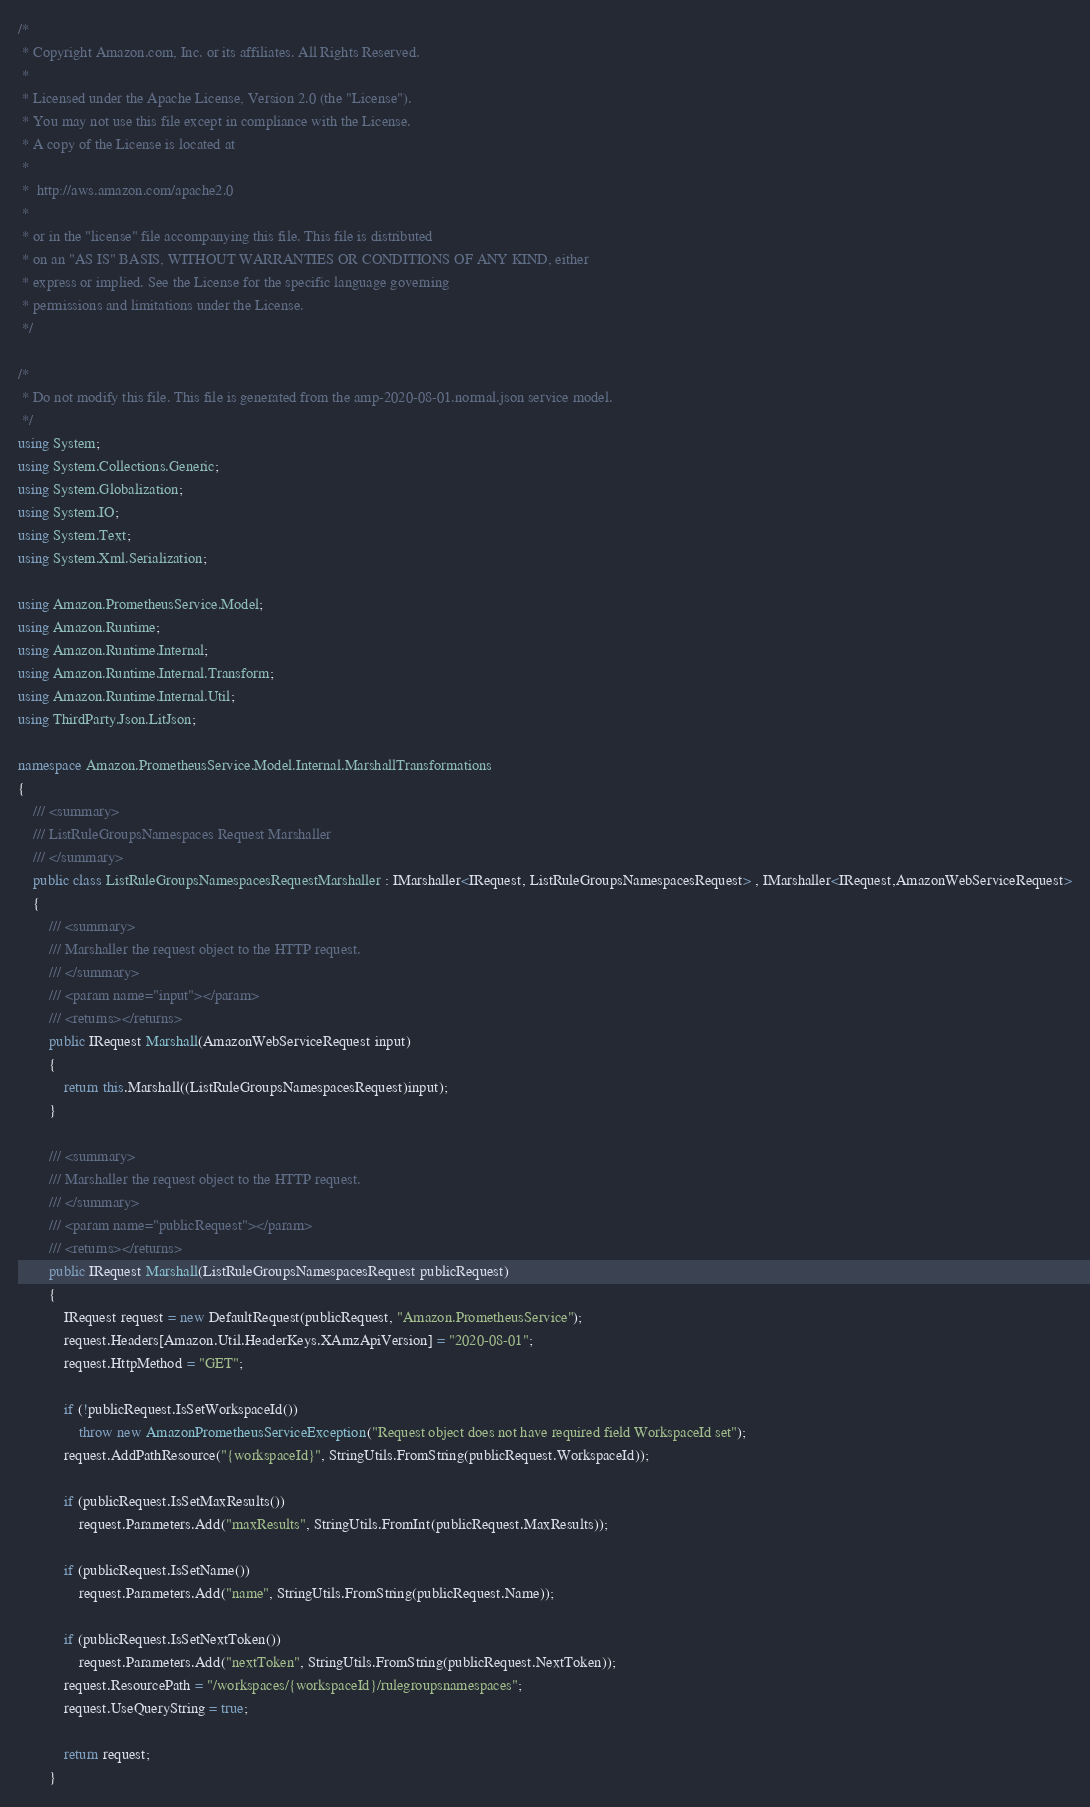<code> <loc_0><loc_0><loc_500><loc_500><_C#_>/*
 * Copyright Amazon.com, Inc. or its affiliates. All Rights Reserved.
 * 
 * Licensed under the Apache License, Version 2.0 (the "License").
 * You may not use this file except in compliance with the License.
 * A copy of the License is located at
 * 
 *  http://aws.amazon.com/apache2.0
 * 
 * or in the "license" file accompanying this file. This file is distributed
 * on an "AS IS" BASIS, WITHOUT WARRANTIES OR CONDITIONS OF ANY KIND, either
 * express or implied. See the License for the specific language governing
 * permissions and limitations under the License.
 */

/*
 * Do not modify this file. This file is generated from the amp-2020-08-01.normal.json service model.
 */
using System;
using System.Collections.Generic;
using System.Globalization;
using System.IO;
using System.Text;
using System.Xml.Serialization;

using Amazon.PrometheusService.Model;
using Amazon.Runtime;
using Amazon.Runtime.Internal;
using Amazon.Runtime.Internal.Transform;
using Amazon.Runtime.Internal.Util;
using ThirdParty.Json.LitJson;

namespace Amazon.PrometheusService.Model.Internal.MarshallTransformations
{
    /// <summary>
    /// ListRuleGroupsNamespaces Request Marshaller
    /// </summary>       
    public class ListRuleGroupsNamespacesRequestMarshaller : IMarshaller<IRequest, ListRuleGroupsNamespacesRequest> , IMarshaller<IRequest,AmazonWebServiceRequest>
    {
        /// <summary>
        /// Marshaller the request object to the HTTP request.
        /// </summary>  
        /// <param name="input"></param>
        /// <returns></returns>
        public IRequest Marshall(AmazonWebServiceRequest input)
        {
            return this.Marshall((ListRuleGroupsNamespacesRequest)input);
        }

        /// <summary>
        /// Marshaller the request object to the HTTP request.
        /// </summary>  
        /// <param name="publicRequest"></param>
        /// <returns></returns>
        public IRequest Marshall(ListRuleGroupsNamespacesRequest publicRequest)
        {
            IRequest request = new DefaultRequest(publicRequest, "Amazon.PrometheusService");
            request.Headers[Amazon.Util.HeaderKeys.XAmzApiVersion] = "2020-08-01";
            request.HttpMethod = "GET";

            if (!publicRequest.IsSetWorkspaceId())
                throw new AmazonPrometheusServiceException("Request object does not have required field WorkspaceId set");
            request.AddPathResource("{workspaceId}", StringUtils.FromString(publicRequest.WorkspaceId));
            
            if (publicRequest.IsSetMaxResults())
                request.Parameters.Add("maxResults", StringUtils.FromInt(publicRequest.MaxResults));
            
            if (publicRequest.IsSetName())
                request.Parameters.Add("name", StringUtils.FromString(publicRequest.Name));
            
            if (publicRequest.IsSetNextToken())
                request.Parameters.Add("nextToken", StringUtils.FromString(publicRequest.NextToken));
            request.ResourcePath = "/workspaces/{workspaceId}/rulegroupsnamespaces";
            request.UseQueryString = true;

            return request;
        }</code> 